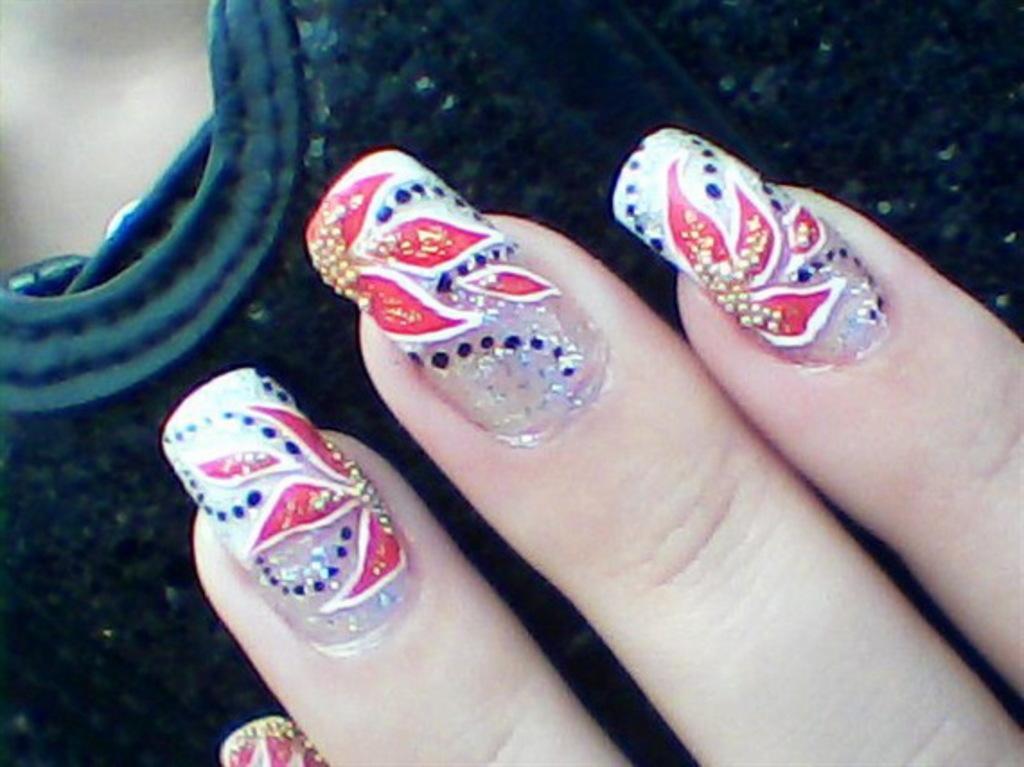Can you describe this image briefly? In the center of the image we can see one dark color object and the fingers of a person with nail paint on the nails. In the background, we can see it is blurred. 